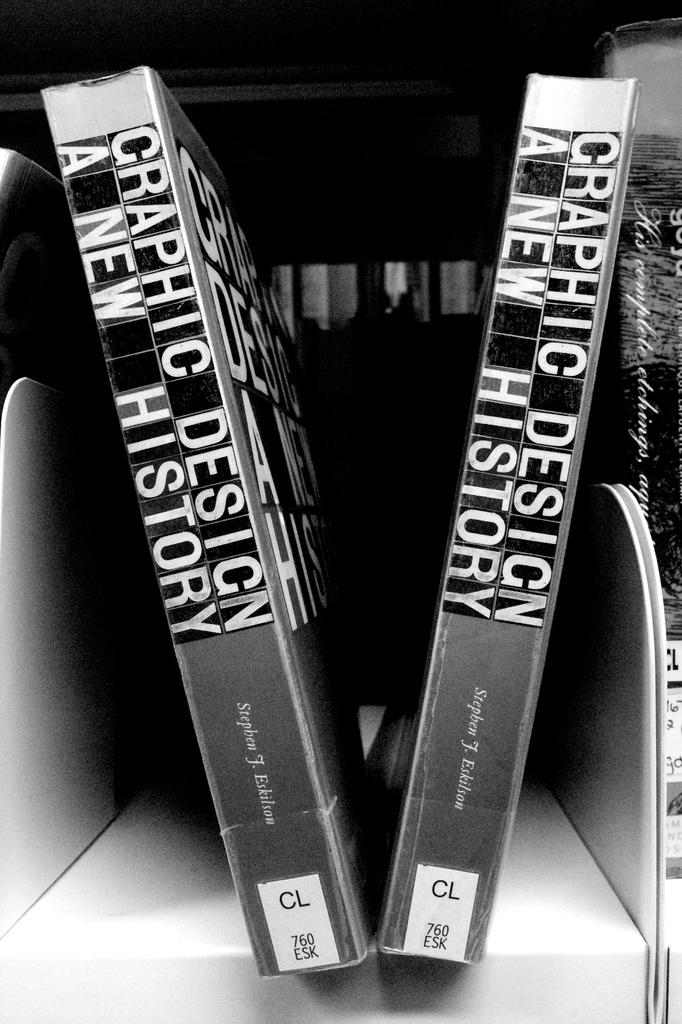Provide a one-sentence caption for the provided image. Two copies of Graphic Design: A New History sit on the shelf. 